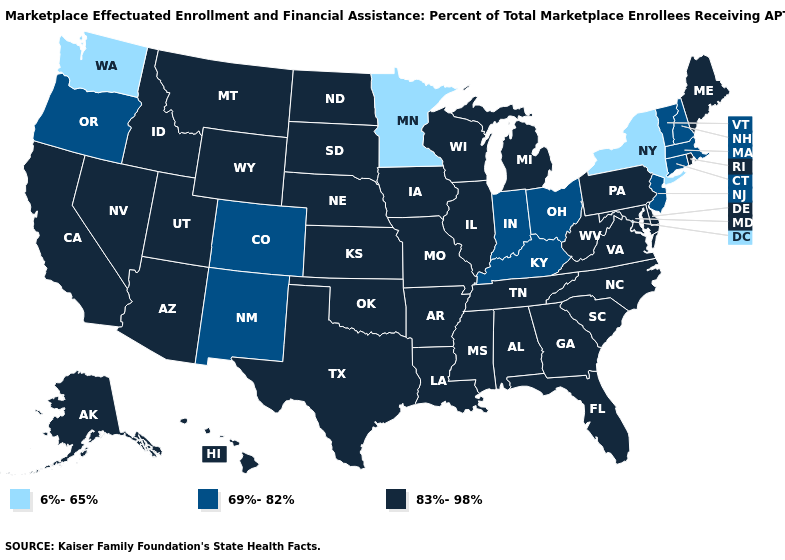Does Ohio have the highest value in the MidWest?
Write a very short answer. No. Does Alabama have the lowest value in the USA?
Be succinct. No. What is the value of Florida?
Be succinct. 83%-98%. Name the states that have a value in the range 6%-65%?
Write a very short answer. Minnesota, New York, Washington. Which states have the lowest value in the USA?
Write a very short answer. Minnesota, New York, Washington. Among the states that border New Jersey , does Delaware have the lowest value?
Write a very short answer. No. What is the lowest value in states that border Kentucky?
Keep it brief. 69%-82%. Does New Mexico have the same value as Hawaii?
Answer briefly. No. Which states have the lowest value in the Northeast?
Be succinct. New York. Name the states that have a value in the range 83%-98%?
Concise answer only. Alabama, Alaska, Arizona, Arkansas, California, Delaware, Florida, Georgia, Hawaii, Idaho, Illinois, Iowa, Kansas, Louisiana, Maine, Maryland, Michigan, Mississippi, Missouri, Montana, Nebraska, Nevada, North Carolina, North Dakota, Oklahoma, Pennsylvania, Rhode Island, South Carolina, South Dakota, Tennessee, Texas, Utah, Virginia, West Virginia, Wisconsin, Wyoming. Name the states that have a value in the range 6%-65%?
Answer briefly. Minnesota, New York, Washington. Does Hawaii have the highest value in the West?
Give a very brief answer. Yes. Does Arizona have the lowest value in the USA?
Quick response, please. No. What is the value of Utah?
Keep it brief. 83%-98%. 